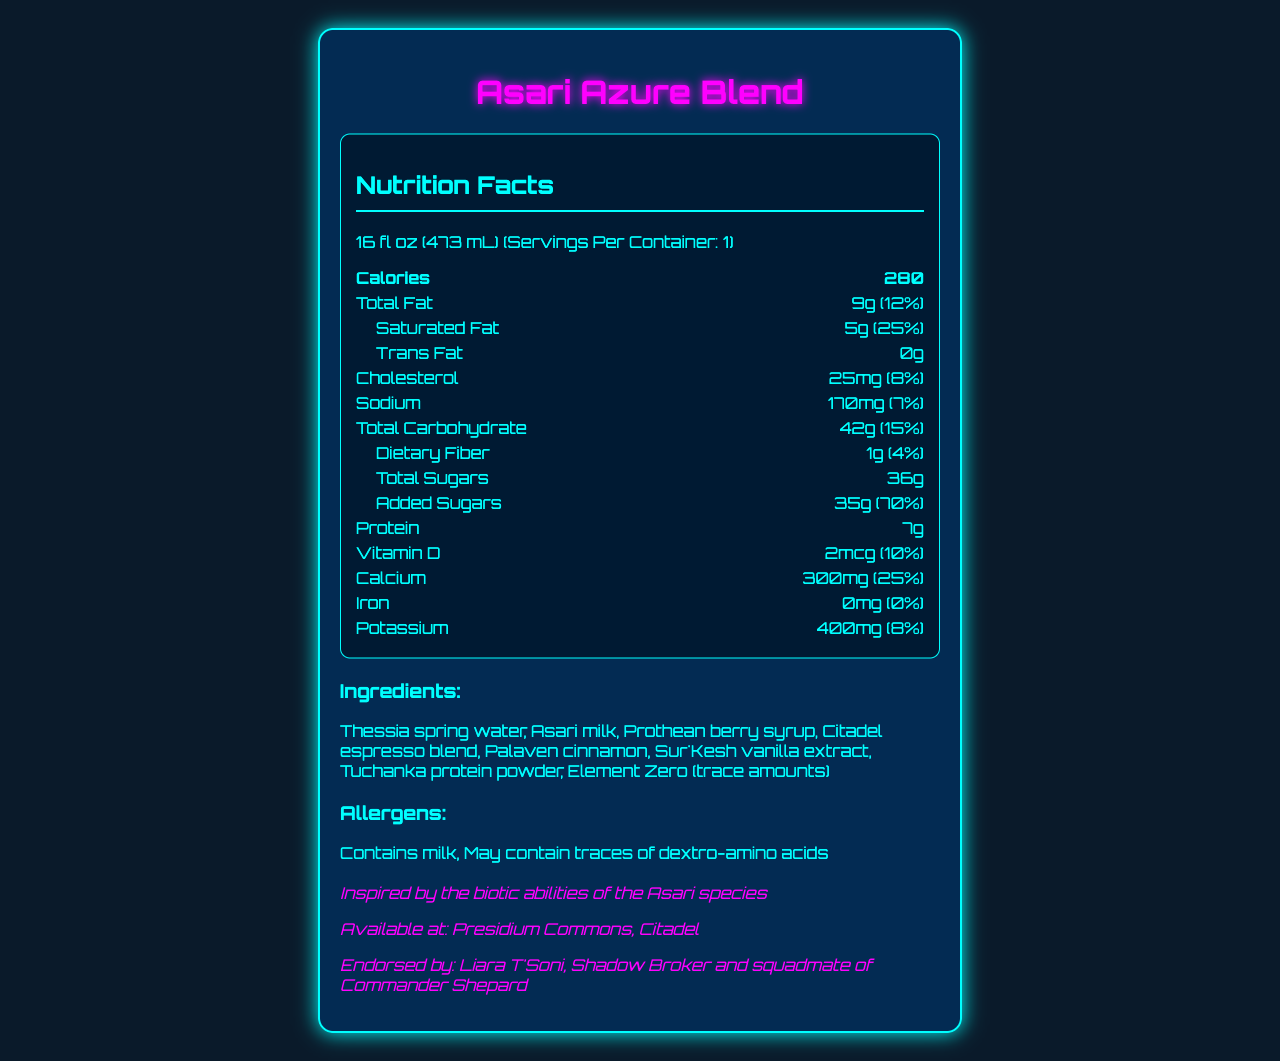what is the serving size? The serving size is listed directly under the product name in the document.
Answer: 16 fl oz (473 mL) how many calories are in one serving of the Asari Azure Blend? The calories are displayed prominently in the nutrition facts section.
Answer: 280 what is the daily value percentage for saturated fat? The daily value percentage for saturated fat is shown next to the amount, listed as 5g (25%).
Answer: 25% how much total carbohydrate does the Asari Azure Blend contain? The amount of total carbohydrate is listed along with its daily value percentage.
Answer: 42g how many grams of added sugars are there? The amount of added sugars is provided in the nutrition facts label.
Answer: 35g which is an ingredient in the Asari Azure Blend? A. Earth water B. Asari milk C. Turian spice Among the options, "Asari milk" is listed under the ingredients section of the document.
Answer: B which nutrient has the highest daily value percentage? A. Saturated fat B. Added sugars C. Calcium Added sugars have the highest daily value percentage at 70%.
Answer: B is the Asari Azure Blend low in cholesterol? The drink contains 25mg of cholesterol, which is 8% of the daily value, not low.
Answer: No summarize the main idea of the document. The document outlines the nutritional information of the Asari Azure Blend, highlighting calories, fats, carbs, sugars, protein, and key minerals and vitamins. Additionally, it lists ingredients and allergens and connects the drink to the Mass Effect universe, endorsed by Liara T'Soni.
Answer: The document provides the nutrition facts for the Asari Azure Blend, detailing the serving size, calories, macronutrients, vitamins, minerals, ingredients, allergens, and its connection to Mass Effect lore, particularly inspired by the Asari species. who is the drink endorsed by in the Mass Effect universe? The document mentions that the drink is endorsed by Liara T'Soni, Shadow Broker, and squadmate of Commander Shepard.
Answer: Liara T'Soni does the Asari Azure Blend contain iron? The document lists iron as 0mg, indicating there is no iron in the drink.
Answer: No how much vitamin D does the Asari Azure Blend provide? The vitamin D content is shown as 2 mcg with a daily value percentage of 10%.
Answer: 2 mcg what is the source of vanilla extract in the Asari Azure Blend? The ingredients section lists "Sur'Kesh vanilla extract" as one of the components.
Answer: Sur'Kesh does the drink contain any dextro-amino acids? The allergens section mentions that the drink may contain traces of dextro-amino acids.
Answer: May contain traces can you tell how much caffeine is in the Asari Azure Blend? The document does not mention the amount of caffeine in the drink.
Answer: Cannot be determined 